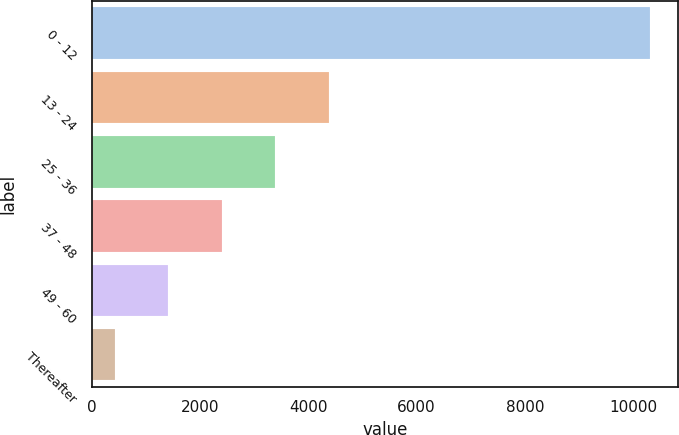Convert chart. <chart><loc_0><loc_0><loc_500><loc_500><bar_chart><fcel>0 - 12<fcel>13 - 24<fcel>25 - 36<fcel>37 - 48<fcel>49 - 60<fcel>Thereafter<nl><fcel>10311<fcel>4378.2<fcel>3389.4<fcel>2400.6<fcel>1411.8<fcel>423<nl></chart> 